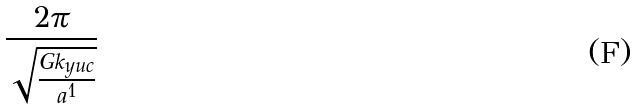Convert formula to latex. <formula><loc_0><loc_0><loc_500><loc_500>\frac { 2 \pi } { \sqrt { \frac { G k _ { y u c } } { a ^ { 1 } } } }</formula> 